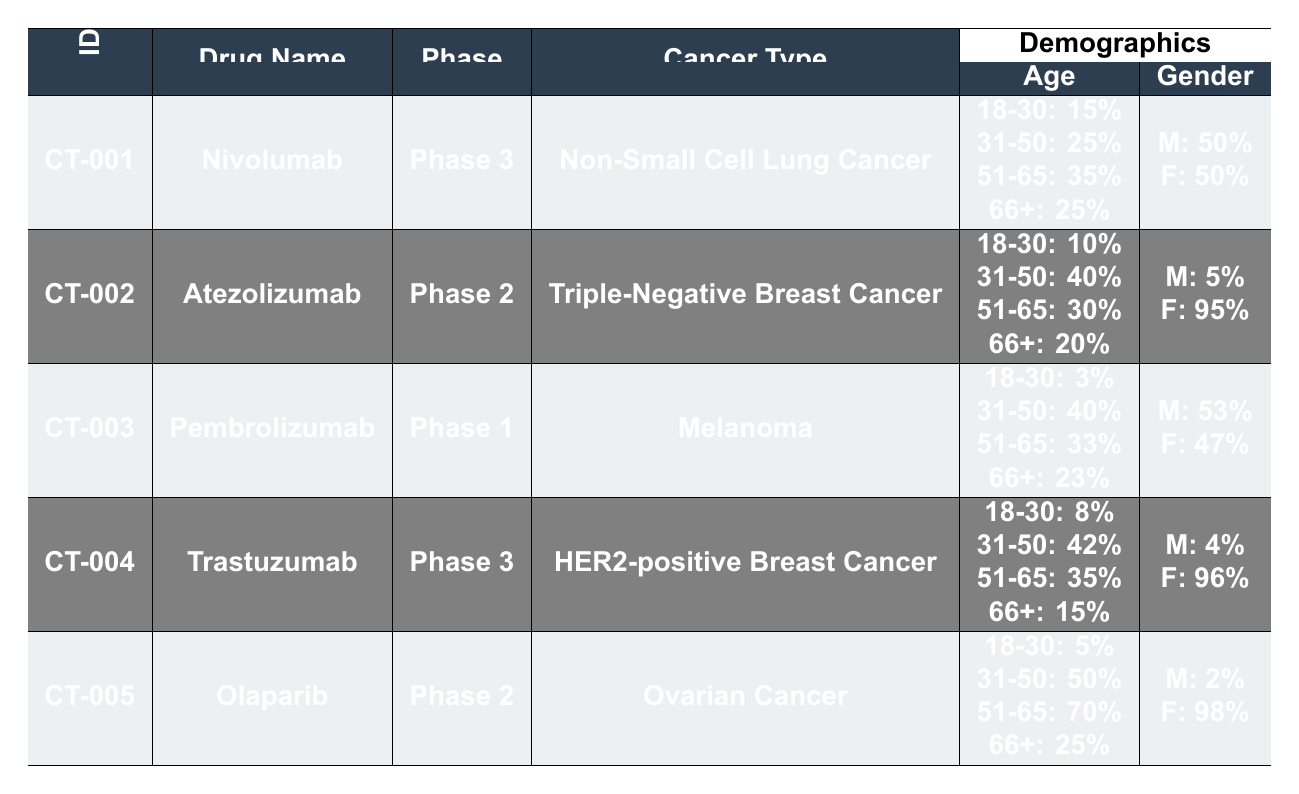What is the total number of participants in the Nivolumab trial? The Nivolumab trial (CT-001) has a total of 600 participants, which is stated directly in the table.
Answer: 600 Which gender had a higher representation in the Atezolizumab trial? In the Atezolizumab trial (CT-002), out of 200 total participants, 10 were male and 190 were female, showing a higher representation of females.
Answer: Female What is the percentage of participants aged 66 and over in the Pembrolizumab trial? The Pembrolizumab trial (CT-003) reports that 35 participants are 66 years old or older out of a total of 150 participants. Calculating the percentage: (35/150) * 100 = 23.33%.
Answer: 23% Is the majority of participants in the Trastuzumab trial over the age of 50? In the Trastuzumab trial (CT-004), participants aged 51-65 and 66 or older account for 35% and 15%, respectively. Adding these percentages gives 50%, indicating that exactly half are over 50, not a majority.
Answer: No What is the average percentage of male participants across all trials? The trials report the male percentages as follows: Nivolumab: 50%, Atezolizumab: 5%, Pembrolizumab: 53%, Trastuzumab: 4%, Olaparib: 2%. Adding these gives 114%, and dividing by 5 trials, the average is 22.8%.
Answer: 22.8% How many more Caucasian participants are there in the Nivolumab trial compared to the Pembrolizumab trial? The Nivolumab trial has 250 Caucasian participants, while the Pembrolizumab trial has 85. The difference is 250 - 85 = 165.
Answer: 165 Are there more participants in Phase 2 trials than in Phase 3 trials combined? The Phase 2 trials (Atezolizumab and Olaparib) have 200 + 300 = 500 participants. The Phase 3 trials (Nivolumab and Trastuzumab) have 600 + 500 = 1100 participants. Since 500 is less than 1100, the answer is no.
Answer: No What proportion of participants aged 31-50 is there in the Olaparib trial? In Olaparib trial (CT-005), 50 out of 300 participants are aged 31-50. The proportion is (50/300) * 100 = 16.67%.
Answer: 16.67% Which cancer type had the most participants in 2022? The Nivolumab trial focusing on Non-Small Cell Lung Cancer had the highest number of participants at 600, which can be confirmed by comparing totals from all trials.
Answer: Non-Small Cell Lung Cancer 